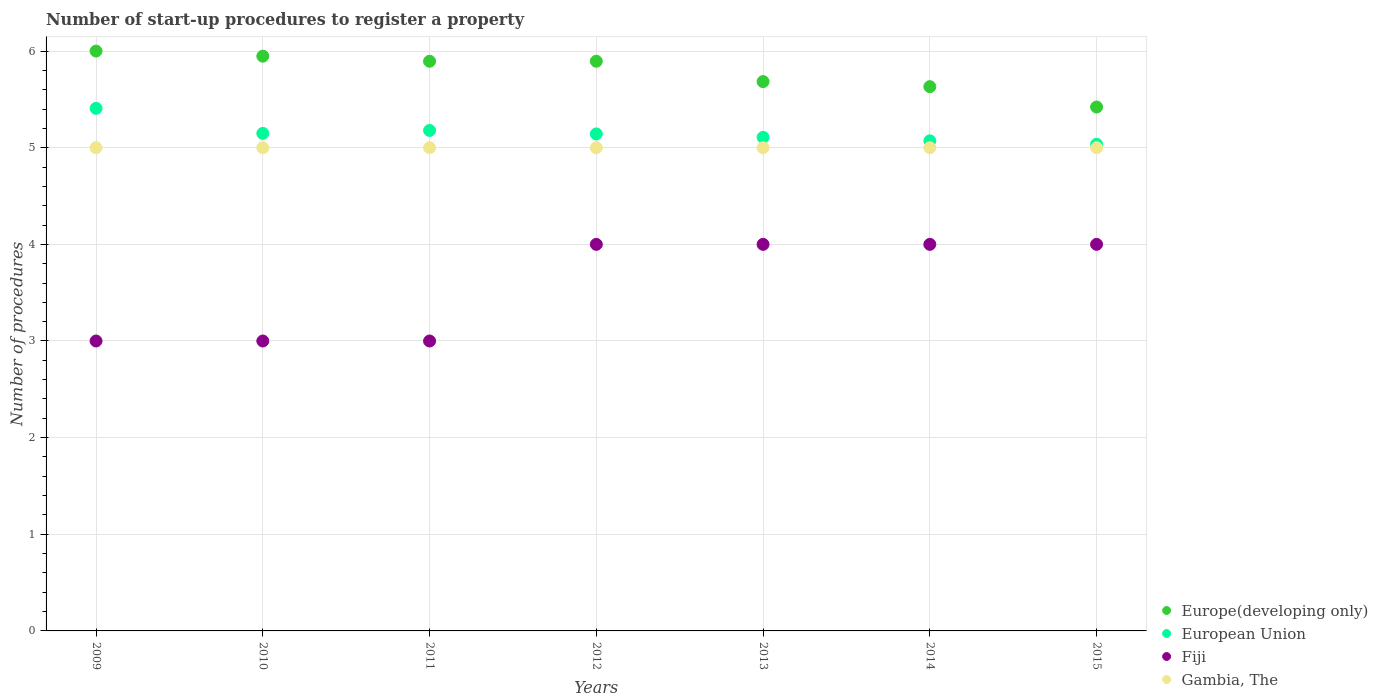What is the number of procedures required to register a property in Fiji in 2013?
Your response must be concise. 4. Across all years, what is the maximum number of procedures required to register a property in European Union?
Offer a very short reply. 5.41. Across all years, what is the minimum number of procedures required to register a property in Fiji?
Your answer should be compact. 3. In which year was the number of procedures required to register a property in Gambia, The maximum?
Your answer should be compact. 2009. In which year was the number of procedures required to register a property in Europe(developing only) minimum?
Make the answer very short. 2015. What is the total number of procedures required to register a property in Europe(developing only) in the graph?
Your response must be concise. 40.47. What is the difference between the number of procedures required to register a property in European Union in 2009 and that in 2012?
Ensure brevity in your answer.  0.26. What is the difference between the number of procedures required to register a property in Europe(developing only) in 2013 and the number of procedures required to register a property in European Union in 2014?
Give a very brief answer. 0.61. What is the average number of procedures required to register a property in European Union per year?
Provide a short and direct response. 5.16. In the year 2011, what is the difference between the number of procedures required to register a property in European Union and number of procedures required to register a property in Gambia, The?
Make the answer very short. 0.18. In how many years, is the number of procedures required to register a property in European Union greater than 5.2?
Ensure brevity in your answer.  1. Is the difference between the number of procedures required to register a property in European Union in 2011 and 2014 greater than the difference between the number of procedures required to register a property in Gambia, The in 2011 and 2014?
Provide a short and direct response. Yes. What is the difference between the highest and the second highest number of procedures required to register a property in Fiji?
Provide a succinct answer. 0. What is the difference between the highest and the lowest number of procedures required to register a property in Europe(developing only)?
Give a very brief answer. 0.58. In how many years, is the number of procedures required to register a property in Fiji greater than the average number of procedures required to register a property in Fiji taken over all years?
Your answer should be very brief. 4. Is it the case that in every year, the sum of the number of procedures required to register a property in Gambia, The and number of procedures required to register a property in Europe(developing only)  is greater than the number of procedures required to register a property in European Union?
Your answer should be compact. Yes. Does the number of procedures required to register a property in Fiji monotonically increase over the years?
Give a very brief answer. No. Is the number of procedures required to register a property in Fiji strictly greater than the number of procedures required to register a property in European Union over the years?
Offer a very short reply. No. How many dotlines are there?
Offer a very short reply. 4. How many years are there in the graph?
Offer a terse response. 7. What is the difference between two consecutive major ticks on the Y-axis?
Your answer should be compact. 1. Does the graph contain any zero values?
Offer a terse response. No. Does the graph contain grids?
Offer a very short reply. Yes. Where does the legend appear in the graph?
Your answer should be compact. Bottom right. What is the title of the graph?
Your response must be concise. Number of start-up procedures to register a property. Does "Cambodia" appear as one of the legend labels in the graph?
Your answer should be compact. No. What is the label or title of the Y-axis?
Keep it short and to the point. Number of procedures. What is the Number of procedures in European Union in 2009?
Your answer should be compact. 5.41. What is the Number of procedures in Fiji in 2009?
Your answer should be compact. 3. What is the Number of procedures of Europe(developing only) in 2010?
Make the answer very short. 5.95. What is the Number of procedures of European Union in 2010?
Make the answer very short. 5.15. What is the Number of procedures of Europe(developing only) in 2011?
Your response must be concise. 5.89. What is the Number of procedures of European Union in 2011?
Offer a terse response. 5.18. What is the Number of procedures in Gambia, The in 2011?
Offer a very short reply. 5. What is the Number of procedures of Europe(developing only) in 2012?
Provide a short and direct response. 5.89. What is the Number of procedures in European Union in 2012?
Provide a succinct answer. 5.14. What is the Number of procedures of Europe(developing only) in 2013?
Your answer should be compact. 5.68. What is the Number of procedures of European Union in 2013?
Provide a succinct answer. 5.11. What is the Number of procedures of Europe(developing only) in 2014?
Ensure brevity in your answer.  5.63. What is the Number of procedures in European Union in 2014?
Your response must be concise. 5.07. What is the Number of procedures of Gambia, The in 2014?
Make the answer very short. 5. What is the Number of procedures in Europe(developing only) in 2015?
Keep it short and to the point. 5.42. What is the Number of procedures of European Union in 2015?
Your answer should be very brief. 5.04. What is the Number of procedures in Fiji in 2015?
Your answer should be compact. 4. What is the Number of procedures in Gambia, The in 2015?
Offer a very short reply. 5. Across all years, what is the maximum Number of procedures of European Union?
Ensure brevity in your answer.  5.41. Across all years, what is the maximum Number of procedures in Fiji?
Give a very brief answer. 4. Across all years, what is the minimum Number of procedures in Europe(developing only)?
Give a very brief answer. 5.42. Across all years, what is the minimum Number of procedures in European Union?
Provide a succinct answer. 5.04. Across all years, what is the minimum Number of procedures of Gambia, The?
Ensure brevity in your answer.  5. What is the total Number of procedures in Europe(developing only) in the graph?
Provide a short and direct response. 40.47. What is the total Number of procedures of European Union in the graph?
Your answer should be very brief. 36.09. What is the total Number of procedures in Gambia, The in the graph?
Ensure brevity in your answer.  35. What is the difference between the Number of procedures of Europe(developing only) in 2009 and that in 2010?
Make the answer very short. 0.05. What is the difference between the Number of procedures of European Union in 2009 and that in 2010?
Provide a short and direct response. 0.26. What is the difference between the Number of procedures in Fiji in 2009 and that in 2010?
Your response must be concise. 0. What is the difference between the Number of procedures of Gambia, The in 2009 and that in 2010?
Give a very brief answer. 0. What is the difference between the Number of procedures in Europe(developing only) in 2009 and that in 2011?
Provide a succinct answer. 0.11. What is the difference between the Number of procedures in European Union in 2009 and that in 2011?
Make the answer very short. 0.23. What is the difference between the Number of procedures of Fiji in 2009 and that in 2011?
Your response must be concise. 0. What is the difference between the Number of procedures of Europe(developing only) in 2009 and that in 2012?
Offer a terse response. 0.11. What is the difference between the Number of procedures of European Union in 2009 and that in 2012?
Your answer should be very brief. 0.26. What is the difference between the Number of procedures in Fiji in 2009 and that in 2012?
Make the answer very short. -1. What is the difference between the Number of procedures in Gambia, The in 2009 and that in 2012?
Provide a succinct answer. 0. What is the difference between the Number of procedures in Europe(developing only) in 2009 and that in 2013?
Make the answer very short. 0.32. What is the difference between the Number of procedures of European Union in 2009 and that in 2013?
Offer a terse response. 0.3. What is the difference between the Number of procedures of Europe(developing only) in 2009 and that in 2014?
Offer a very short reply. 0.37. What is the difference between the Number of procedures in European Union in 2009 and that in 2014?
Your response must be concise. 0.34. What is the difference between the Number of procedures of Europe(developing only) in 2009 and that in 2015?
Keep it short and to the point. 0.58. What is the difference between the Number of procedures of European Union in 2009 and that in 2015?
Your answer should be compact. 0.37. What is the difference between the Number of procedures of Gambia, The in 2009 and that in 2015?
Provide a succinct answer. 0. What is the difference between the Number of procedures in Europe(developing only) in 2010 and that in 2011?
Your answer should be very brief. 0.05. What is the difference between the Number of procedures of European Union in 2010 and that in 2011?
Ensure brevity in your answer.  -0.03. What is the difference between the Number of procedures in Fiji in 2010 and that in 2011?
Give a very brief answer. 0. What is the difference between the Number of procedures of Europe(developing only) in 2010 and that in 2012?
Provide a succinct answer. 0.05. What is the difference between the Number of procedures in European Union in 2010 and that in 2012?
Provide a short and direct response. 0.01. What is the difference between the Number of procedures of Gambia, The in 2010 and that in 2012?
Make the answer very short. 0. What is the difference between the Number of procedures in Europe(developing only) in 2010 and that in 2013?
Keep it short and to the point. 0.26. What is the difference between the Number of procedures of European Union in 2010 and that in 2013?
Ensure brevity in your answer.  0.04. What is the difference between the Number of procedures in Fiji in 2010 and that in 2013?
Your answer should be very brief. -1. What is the difference between the Number of procedures in Gambia, The in 2010 and that in 2013?
Your response must be concise. 0. What is the difference between the Number of procedures in Europe(developing only) in 2010 and that in 2014?
Provide a short and direct response. 0.32. What is the difference between the Number of procedures of European Union in 2010 and that in 2014?
Offer a very short reply. 0.08. What is the difference between the Number of procedures of Gambia, The in 2010 and that in 2014?
Make the answer very short. 0. What is the difference between the Number of procedures of Europe(developing only) in 2010 and that in 2015?
Your answer should be very brief. 0.53. What is the difference between the Number of procedures in European Union in 2010 and that in 2015?
Keep it short and to the point. 0.11. What is the difference between the Number of procedures of Fiji in 2010 and that in 2015?
Provide a short and direct response. -1. What is the difference between the Number of procedures of Europe(developing only) in 2011 and that in 2012?
Offer a very short reply. 0. What is the difference between the Number of procedures of European Union in 2011 and that in 2012?
Provide a succinct answer. 0.04. What is the difference between the Number of procedures of Europe(developing only) in 2011 and that in 2013?
Make the answer very short. 0.21. What is the difference between the Number of procedures in European Union in 2011 and that in 2013?
Give a very brief answer. 0.07. What is the difference between the Number of procedures of Fiji in 2011 and that in 2013?
Offer a terse response. -1. What is the difference between the Number of procedures in Europe(developing only) in 2011 and that in 2014?
Your answer should be very brief. 0.26. What is the difference between the Number of procedures of European Union in 2011 and that in 2014?
Your answer should be very brief. 0.11. What is the difference between the Number of procedures in Fiji in 2011 and that in 2014?
Keep it short and to the point. -1. What is the difference between the Number of procedures in Europe(developing only) in 2011 and that in 2015?
Ensure brevity in your answer.  0.47. What is the difference between the Number of procedures in European Union in 2011 and that in 2015?
Provide a succinct answer. 0.14. What is the difference between the Number of procedures in Gambia, The in 2011 and that in 2015?
Your answer should be very brief. 0. What is the difference between the Number of procedures of Europe(developing only) in 2012 and that in 2013?
Ensure brevity in your answer.  0.21. What is the difference between the Number of procedures in European Union in 2012 and that in 2013?
Make the answer very short. 0.04. What is the difference between the Number of procedures in Fiji in 2012 and that in 2013?
Ensure brevity in your answer.  0. What is the difference between the Number of procedures of Gambia, The in 2012 and that in 2013?
Provide a succinct answer. 0. What is the difference between the Number of procedures in Europe(developing only) in 2012 and that in 2014?
Make the answer very short. 0.26. What is the difference between the Number of procedures of European Union in 2012 and that in 2014?
Offer a terse response. 0.07. What is the difference between the Number of procedures in Gambia, The in 2012 and that in 2014?
Give a very brief answer. 0. What is the difference between the Number of procedures of Europe(developing only) in 2012 and that in 2015?
Your answer should be very brief. 0.47. What is the difference between the Number of procedures of European Union in 2012 and that in 2015?
Ensure brevity in your answer.  0.11. What is the difference between the Number of procedures of Fiji in 2012 and that in 2015?
Provide a short and direct response. 0. What is the difference between the Number of procedures in Gambia, The in 2012 and that in 2015?
Your response must be concise. 0. What is the difference between the Number of procedures of Europe(developing only) in 2013 and that in 2014?
Offer a very short reply. 0.05. What is the difference between the Number of procedures of European Union in 2013 and that in 2014?
Your response must be concise. 0.04. What is the difference between the Number of procedures in Gambia, The in 2013 and that in 2014?
Offer a very short reply. 0. What is the difference between the Number of procedures of Europe(developing only) in 2013 and that in 2015?
Ensure brevity in your answer.  0.26. What is the difference between the Number of procedures in European Union in 2013 and that in 2015?
Your response must be concise. 0.07. What is the difference between the Number of procedures of Fiji in 2013 and that in 2015?
Give a very brief answer. 0. What is the difference between the Number of procedures in Gambia, The in 2013 and that in 2015?
Ensure brevity in your answer.  0. What is the difference between the Number of procedures in Europe(developing only) in 2014 and that in 2015?
Make the answer very short. 0.21. What is the difference between the Number of procedures in European Union in 2014 and that in 2015?
Ensure brevity in your answer.  0.04. What is the difference between the Number of procedures in Fiji in 2014 and that in 2015?
Keep it short and to the point. 0. What is the difference between the Number of procedures of Europe(developing only) in 2009 and the Number of procedures of European Union in 2010?
Give a very brief answer. 0.85. What is the difference between the Number of procedures of Europe(developing only) in 2009 and the Number of procedures of Fiji in 2010?
Offer a terse response. 3. What is the difference between the Number of procedures of European Union in 2009 and the Number of procedures of Fiji in 2010?
Offer a very short reply. 2.41. What is the difference between the Number of procedures of European Union in 2009 and the Number of procedures of Gambia, The in 2010?
Ensure brevity in your answer.  0.41. What is the difference between the Number of procedures of Europe(developing only) in 2009 and the Number of procedures of European Union in 2011?
Offer a terse response. 0.82. What is the difference between the Number of procedures in European Union in 2009 and the Number of procedures in Fiji in 2011?
Your response must be concise. 2.41. What is the difference between the Number of procedures of European Union in 2009 and the Number of procedures of Gambia, The in 2011?
Provide a succinct answer. 0.41. What is the difference between the Number of procedures of Europe(developing only) in 2009 and the Number of procedures of Gambia, The in 2012?
Offer a very short reply. 1. What is the difference between the Number of procedures in European Union in 2009 and the Number of procedures in Fiji in 2012?
Give a very brief answer. 1.41. What is the difference between the Number of procedures of European Union in 2009 and the Number of procedures of Gambia, The in 2012?
Your answer should be very brief. 0.41. What is the difference between the Number of procedures in Europe(developing only) in 2009 and the Number of procedures in European Union in 2013?
Provide a succinct answer. 0.89. What is the difference between the Number of procedures in Europe(developing only) in 2009 and the Number of procedures in Fiji in 2013?
Provide a succinct answer. 2. What is the difference between the Number of procedures of European Union in 2009 and the Number of procedures of Fiji in 2013?
Your answer should be compact. 1.41. What is the difference between the Number of procedures of European Union in 2009 and the Number of procedures of Gambia, The in 2013?
Keep it short and to the point. 0.41. What is the difference between the Number of procedures of Fiji in 2009 and the Number of procedures of Gambia, The in 2013?
Provide a short and direct response. -2. What is the difference between the Number of procedures in Europe(developing only) in 2009 and the Number of procedures in Gambia, The in 2014?
Give a very brief answer. 1. What is the difference between the Number of procedures of European Union in 2009 and the Number of procedures of Fiji in 2014?
Offer a very short reply. 1.41. What is the difference between the Number of procedures of European Union in 2009 and the Number of procedures of Gambia, The in 2014?
Offer a terse response. 0.41. What is the difference between the Number of procedures in Fiji in 2009 and the Number of procedures in Gambia, The in 2014?
Make the answer very short. -2. What is the difference between the Number of procedures of Europe(developing only) in 2009 and the Number of procedures of European Union in 2015?
Keep it short and to the point. 0.96. What is the difference between the Number of procedures in Europe(developing only) in 2009 and the Number of procedures in Fiji in 2015?
Provide a succinct answer. 2. What is the difference between the Number of procedures in Europe(developing only) in 2009 and the Number of procedures in Gambia, The in 2015?
Your answer should be very brief. 1. What is the difference between the Number of procedures of European Union in 2009 and the Number of procedures of Fiji in 2015?
Make the answer very short. 1.41. What is the difference between the Number of procedures in European Union in 2009 and the Number of procedures in Gambia, The in 2015?
Give a very brief answer. 0.41. What is the difference between the Number of procedures in Fiji in 2009 and the Number of procedures in Gambia, The in 2015?
Make the answer very short. -2. What is the difference between the Number of procedures of Europe(developing only) in 2010 and the Number of procedures of European Union in 2011?
Offer a terse response. 0.77. What is the difference between the Number of procedures of Europe(developing only) in 2010 and the Number of procedures of Fiji in 2011?
Your response must be concise. 2.95. What is the difference between the Number of procedures of Europe(developing only) in 2010 and the Number of procedures of Gambia, The in 2011?
Give a very brief answer. 0.95. What is the difference between the Number of procedures in European Union in 2010 and the Number of procedures in Fiji in 2011?
Your answer should be compact. 2.15. What is the difference between the Number of procedures in European Union in 2010 and the Number of procedures in Gambia, The in 2011?
Give a very brief answer. 0.15. What is the difference between the Number of procedures in Europe(developing only) in 2010 and the Number of procedures in European Union in 2012?
Give a very brief answer. 0.8. What is the difference between the Number of procedures of Europe(developing only) in 2010 and the Number of procedures of Fiji in 2012?
Offer a terse response. 1.95. What is the difference between the Number of procedures of Europe(developing only) in 2010 and the Number of procedures of Gambia, The in 2012?
Ensure brevity in your answer.  0.95. What is the difference between the Number of procedures in European Union in 2010 and the Number of procedures in Fiji in 2012?
Provide a succinct answer. 1.15. What is the difference between the Number of procedures of European Union in 2010 and the Number of procedures of Gambia, The in 2012?
Provide a succinct answer. 0.15. What is the difference between the Number of procedures of Fiji in 2010 and the Number of procedures of Gambia, The in 2012?
Give a very brief answer. -2. What is the difference between the Number of procedures in Europe(developing only) in 2010 and the Number of procedures in European Union in 2013?
Your answer should be very brief. 0.84. What is the difference between the Number of procedures of Europe(developing only) in 2010 and the Number of procedures of Fiji in 2013?
Your response must be concise. 1.95. What is the difference between the Number of procedures of Europe(developing only) in 2010 and the Number of procedures of Gambia, The in 2013?
Ensure brevity in your answer.  0.95. What is the difference between the Number of procedures of European Union in 2010 and the Number of procedures of Fiji in 2013?
Keep it short and to the point. 1.15. What is the difference between the Number of procedures in European Union in 2010 and the Number of procedures in Gambia, The in 2013?
Provide a succinct answer. 0.15. What is the difference between the Number of procedures in Europe(developing only) in 2010 and the Number of procedures in European Union in 2014?
Make the answer very short. 0.88. What is the difference between the Number of procedures of Europe(developing only) in 2010 and the Number of procedures of Fiji in 2014?
Provide a short and direct response. 1.95. What is the difference between the Number of procedures of Europe(developing only) in 2010 and the Number of procedures of Gambia, The in 2014?
Keep it short and to the point. 0.95. What is the difference between the Number of procedures of European Union in 2010 and the Number of procedures of Fiji in 2014?
Your response must be concise. 1.15. What is the difference between the Number of procedures in European Union in 2010 and the Number of procedures in Gambia, The in 2014?
Ensure brevity in your answer.  0.15. What is the difference between the Number of procedures of Europe(developing only) in 2010 and the Number of procedures of European Union in 2015?
Offer a terse response. 0.91. What is the difference between the Number of procedures of Europe(developing only) in 2010 and the Number of procedures of Fiji in 2015?
Provide a succinct answer. 1.95. What is the difference between the Number of procedures of Europe(developing only) in 2010 and the Number of procedures of Gambia, The in 2015?
Provide a short and direct response. 0.95. What is the difference between the Number of procedures of European Union in 2010 and the Number of procedures of Fiji in 2015?
Provide a short and direct response. 1.15. What is the difference between the Number of procedures of European Union in 2010 and the Number of procedures of Gambia, The in 2015?
Make the answer very short. 0.15. What is the difference between the Number of procedures of Europe(developing only) in 2011 and the Number of procedures of European Union in 2012?
Provide a succinct answer. 0.75. What is the difference between the Number of procedures in Europe(developing only) in 2011 and the Number of procedures in Fiji in 2012?
Your answer should be compact. 1.89. What is the difference between the Number of procedures in Europe(developing only) in 2011 and the Number of procedures in Gambia, The in 2012?
Provide a succinct answer. 0.89. What is the difference between the Number of procedures in European Union in 2011 and the Number of procedures in Fiji in 2012?
Your answer should be very brief. 1.18. What is the difference between the Number of procedures in European Union in 2011 and the Number of procedures in Gambia, The in 2012?
Provide a succinct answer. 0.18. What is the difference between the Number of procedures of Europe(developing only) in 2011 and the Number of procedures of European Union in 2013?
Provide a succinct answer. 0.79. What is the difference between the Number of procedures of Europe(developing only) in 2011 and the Number of procedures of Fiji in 2013?
Offer a terse response. 1.89. What is the difference between the Number of procedures in Europe(developing only) in 2011 and the Number of procedures in Gambia, The in 2013?
Your answer should be very brief. 0.89. What is the difference between the Number of procedures of European Union in 2011 and the Number of procedures of Fiji in 2013?
Offer a terse response. 1.18. What is the difference between the Number of procedures in European Union in 2011 and the Number of procedures in Gambia, The in 2013?
Make the answer very short. 0.18. What is the difference between the Number of procedures of Europe(developing only) in 2011 and the Number of procedures of European Union in 2014?
Your response must be concise. 0.82. What is the difference between the Number of procedures of Europe(developing only) in 2011 and the Number of procedures of Fiji in 2014?
Provide a short and direct response. 1.89. What is the difference between the Number of procedures of Europe(developing only) in 2011 and the Number of procedures of Gambia, The in 2014?
Provide a short and direct response. 0.89. What is the difference between the Number of procedures in European Union in 2011 and the Number of procedures in Fiji in 2014?
Provide a succinct answer. 1.18. What is the difference between the Number of procedures in European Union in 2011 and the Number of procedures in Gambia, The in 2014?
Give a very brief answer. 0.18. What is the difference between the Number of procedures of Fiji in 2011 and the Number of procedures of Gambia, The in 2014?
Your response must be concise. -2. What is the difference between the Number of procedures of Europe(developing only) in 2011 and the Number of procedures of European Union in 2015?
Offer a terse response. 0.86. What is the difference between the Number of procedures in Europe(developing only) in 2011 and the Number of procedures in Fiji in 2015?
Ensure brevity in your answer.  1.89. What is the difference between the Number of procedures in Europe(developing only) in 2011 and the Number of procedures in Gambia, The in 2015?
Offer a very short reply. 0.89. What is the difference between the Number of procedures in European Union in 2011 and the Number of procedures in Fiji in 2015?
Offer a terse response. 1.18. What is the difference between the Number of procedures of European Union in 2011 and the Number of procedures of Gambia, The in 2015?
Your answer should be compact. 0.18. What is the difference between the Number of procedures of Europe(developing only) in 2012 and the Number of procedures of European Union in 2013?
Keep it short and to the point. 0.79. What is the difference between the Number of procedures of Europe(developing only) in 2012 and the Number of procedures of Fiji in 2013?
Make the answer very short. 1.89. What is the difference between the Number of procedures of Europe(developing only) in 2012 and the Number of procedures of Gambia, The in 2013?
Provide a short and direct response. 0.89. What is the difference between the Number of procedures in European Union in 2012 and the Number of procedures in Gambia, The in 2013?
Offer a very short reply. 0.14. What is the difference between the Number of procedures in Europe(developing only) in 2012 and the Number of procedures in European Union in 2014?
Keep it short and to the point. 0.82. What is the difference between the Number of procedures in Europe(developing only) in 2012 and the Number of procedures in Fiji in 2014?
Provide a succinct answer. 1.89. What is the difference between the Number of procedures of Europe(developing only) in 2012 and the Number of procedures of Gambia, The in 2014?
Provide a succinct answer. 0.89. What is the difference between the Number of procedures of European Union in 2012 and the Number of procedures of Gambia, The in 2014?
Give a very brief answer. 0.14. What is the difference between the Number of procedures in Europe(developing only) in 2012 and the Number of procedures in European Union in 2015?
Your answer should be compact. 0.86. What is the difference between the Number of procedures in Europe(developing only) in 2012 and the Number of procedures in Fiji in 2015?
Give a very brief answer. 1.89. What is the difference between the Number of procedures in Europe(developing only) in 2012 and the Number of procedures in Gambia, The in 2015?
Make the answer very short. 0.89. What is the difference between the Number of procedures in European Union in 2012 and the Number of procedures in Gambia, The in 2015?
Offer a terse response. 0.14. What is the difference between the Number of procedures in Fiji in 2012 and the Number of procedures in Gambia, The in 2015?
Make the answer very short. -1. What is the difference between the Number of procedures of Europe(developing only) in 2013 and the Number of procedures of European Union in 2014?
Keep it short and to the point. 0.61. What is the difference between the Number of procedures of Europe(developing only) in 2013 and the Number of procedures of Fiji in 2014?
Your answer should be very brief. 1.68. What is the difference between the Number of procedures of Europe(developing only) in 2013 and the Number of procedures of Gambia, The in 2014?
Provide a short and direct response. 0.68. What is the difference between the Number of procedures of European Union in 2013 and the Number of procedures of Fiji in 2014?
Keep it short and to the point. 1.11. What is the difference between the Number of procedures in European Union in 2013 and the Number of procedures in Gambia, The in 2014?
Offer a very short reply. 0.11. What is the difference between the Number of procedures in Europe(developing only) in 2013 and the Number of procedures in European Union in 2015?
Offer a terse response. 0.65. What is the difference between the Number of procedures in Europe(developing only) in 2013 and the Number of procedures in Fiji in 2015?
Make the answer very short. 1.68. What is the difference between the Number of procedures of Europe(developing only) in 2013 and the Number of procedures of Gambia, The in 2015?
Offer a very short reply. 0.68. What is the difference between the Number of procedures in European Union in 2013 and the Number of procedures in Fiji in 2015?
Make the answer very short. 1.11. What is the difference between the Number of procedures of European Union in 2013 and the Number of procedures of Gambia, The in 2015?
Offer a very short reply. 0.11. What is the difference between the Number of procedures of Europe(developing only) in 2014 and the Number of procedures of European Union in 2015?
Your answer should be compact. 0.6. What is the difference between the Number of procedures in Europe(developing only) in 2014 and the Number of procedures in Fiji in 2015?
Keep it short and to the point. 1.63. What is the difference between the Number of procedures in Europe(developing only) in 2014 and the Number of procedures in Gambia, The in 2015?
Your answer should be very brief. 0.63. What is the difference between the Number of procedures of European Union in 2014 and the Number of procedures of Fiji in 2015?
Your answer should be compact. 1.07. What is the difference between the Number of procedures of European Union in 2014 and the Number of procedures of Gambia, The in 2015?
Give a very brief answer. 0.07. What is the average Number of procedures in Europe(developing only) per year?
Make the answer very short. 5.78. What is the average Number of procedures of European Union per year?
Your response must be concise. 5.16. What is the average Number of procedures in Fiji per year?
Provide a short and direct response. 3.57. What is the average Number of procedures of Gambia, The per year?
Keep it short and to the point. 5. In the year 2009, what is the difference between the Number of procedures of Europe(developing only) and Number of procedures of European Union?
Your response must be concise. 0.59. In the year 2009, what is the difference between the Number of procedures in European Union and Number of procedures in Fiji?
Your answer should be very brief. 2.41. In the year 2009, what is the difference between the Number of procedures in European Union and Number of procedures in Gambia, The?
Keep it short and to the point. 0.41. In the year 2009, what is the difference between the Number of procedures of Fiji and Number of procedures of Gambia, The?
Your answer should be compact. -2. In the year 2010, what is the difference between the Number of procedures of Europe(developing only) and Number of procedures of European Union?
Provide a short and direct response. 0.8. In the year 2010, what is the difference between the Number of procedures of Europe(developing only) and Number of procedures of Fiji?
Your response must be concise. 2.95. In the year 2010, what is the difference between the Number of procedures of Europe(developing only) and Number of procedures of Gambia, The?
Your answer should be compact. 0.95. In the year 2010, what is the difference between the Number of procedures of European Union and Number of procedures of Fiji?
Your answer should be very brief. 2.15. In the year 2010, what is the difference between the Number of procedures in European Union and Number of procedures in Gambia, The?
Keep it short and to the point. 0.15. In the year 2010, what is the difference between the Number of procedures in Fiji and Number of procedures in Gambia, The?
Ensure brevity in your answer.  -2. In the year 2011, what is the difference between the Number of procedures in Europe(developing only) and Number of procedures in European Union?
Keep it short and to the point. 0.72. In the year 2011, what is the difference between the Number of procedures in Europe(developing only) and Number of procedures in Fiji?
Offer a very short reply. 2.89. In the year 2011, what is the difference between the Number of procedures of Europe(developing only) and Number of procedures of Gambia, The?
Offer a terse response. 0.89. In the year 2011, what is the difference between the Number of procedures in European Union and Number of procedures in Fiji?
Ensure brevity in your answer.  2.18. In the year 2011, what is the difference between the Number of procedures in European Union and Number of procedures in Gambia, The?
Make the answer very short. 0.18. In the year 2012, what is the difference between the Number of procedures in Europe(developing only) and Number of procedures in European Union?
Offer a very short reply. 0.75. In the year 2012, what is the difference between the Number of procedures in Europe(developing only) and Number of procedures in Fiji?
Provide a short and direct response. 1.89. In the year 2012, what is the difference between the Number of procedures of Europe(developing only) and Number of procedures of Gambia, The?
Provide a succinct answer. 0.89. In the year 2012, what is the difference between the Number of procedures of European Union and Number of procedures of Fiji?
Your answer should be very brief. 1.14. In the year 2012, what is the difference between the Number of procedures in European Union and Number of procedures in Gambia, The?
Provide a succinct answer. 0.14. In the year 2012, what is the difference between the Number of procedures of Fiji and Number of procedures of Gambia, The?
Make the answer very short. -1. In the year 2013, what is the difference between the Number of procedures of Europe(developing only) and Number of procedures of European Union?
Provide a succinct answer. 0.58. In the year 2013, what is the difference between the Number of procedures in Europe(developing only) and Number of procedures in Fiji?
Your answer should be compact. 1.68. In the year 2013, what is the difference between the Number of procedures in Europe(developing only) and Number of procedures in Gambia, The?
Your response must be concise. 0.68. In the year 2013, what is the difference between the Number of procedures in European Union and Number of procedures in Fiji?
Make the answer very short. 1.11. In the year 2013, what is the difference between the Number of procedures of European Union and Number of procedures of Gambia, The?
Keep it short and to the point. 0.11. In the year 2014, what is the difference between the Number of procedures of Europe(developing only) and Number of procedures of European Union?
Your answer should be compact. 0.56. In the year 2014, what is the difference between the Number of procedures in Europe(developing only) and Number of procedures in Fiji?
Keep it short and to the point. 1.63. In the year 2014, what is the difference between the Number of procedures in Europe(developing only) and Number of procedures in Gambia, The?
Your answer should be very brief. 0.63. In the year 2014, what is the difference between the Number of procedures in European Union and Number of procedures in Fiji?
Make the answer very short. 1.07. In the year 2014, what is the difference between the Number of procedures in European Union and Number of procedures in Gambia, The?
Offer a very short reply. 0.07. In the year 2014, what is the difference between the Number of procedures of Fiji and Number of procedures of Gambia, The?
Offer a terse response. -1. In the year 2015, what is the difference between the Number of procedures in Europe(developing only) and Number of procedures in European Union?
Ensure brevity in your answer.  0.39. In the year 2015, what is the difference between the Number of procedures in Europe(developing only) and Number of procedures in Fiji?
Your answer should be very brief. 1.42. In the year 2015, what is the difference between the Number of procedures in Europe(developing only) and Number of procedures in Gambia, The?
Your response must be concise. 0.42. In the year 2015, what is the difference between the Number of procedures in European Union and Number of procedures in Fiji?
Ensure brevity in your answer.  1.04. In the year 2015, what is the difference between the Number of procedures of European Union and Number of procedures of Gambia, The?
Your answer should be very brief. 0.04. What is the ratio of the Number of procedures in Europe(developing only) in 2009 to that in 2010?
Keep it short and to the point. 1.01. What is the ratio of the Number of procedures in European Union in 2009 to that in 2010?
Offer a very short reply. 1.05. What is the ratio of the Number of procedures of Fiji in 2009 to that in 2010?
Make the answer very short. 1. What is the ratio of the Number of procedures of Gambia, The in 2009 to that in 2010?
Make the answer very short. 1. What is the ratio of the Number of procedures in Europe(developing only) in 2009 to that in 2011?
Offer a terse response. 1.02. What is the ratio of the Number of procedures in European Union in 2009 to that in 2011?
Keep it short and to the point. 1.04. What is the ratio of the Number of procedures of Fiji in 2009 to that in 2011?
Give a very brief answer. 1. What is the ratio of the Number of procedures in Europe(developing only) in 2009 to that in 2012?
Offer a terse response. 1.02. What is the ratio of the Number of procedures of European Union in 2009 to that in 2012?
Provide a succinct answer. 1.05. What is the ratio of the Number of procedures in Fiji in 2009 to that in 2012?
Your answer should be compact. 0.75. What is the ratio of the Number of procedures in Europe(developing only) in 2009 to that in 2013?
Make the answer very short. 1.06. What is the ratio of the Number of procedures of European Union in 2009 to that in 2013?
Give a very brief answer. 1.06. What is the ratio of the Number of procedures of Fiji in 2009 to that in 2013?
Your answer should be compact. 0.75. What is the ratio of the Number of procedures in Europe(developing only) in 2009 to that in 2014?
Keep it short and to the point. 1.07. What is the ratio of the Number of procedures of European Union in 2009 to that in 2014?
Your response must be concise. 1.07. What is the ratio of the Number of procedures in Europe(developing only) in 2009 to that in 2015?
Your answer should be very brief. 1.11. What is the ratio of the Number of procedures in European Union in 2009 to that in 2015?
Your response must be concise. 1.07. What is the ratio of the Number of procedures in Gambia, The in 2009 to that in 2015?
Keep it short and to the point. 1. What is the ratio of the Number of procedures of Europe(developing only) in 2010 to that in 2011?
Provide a succinct answer. 1.01. What is the ratio of the Number of procedures of European Union in 2010 to that in 2011?
Offer a terse response. 0.99. What is the ratio of the Number of procedures in Fiji in 2010 to that in 2011?
Make the answer very short. 1. What is the ratio of the Number of procedures in Europe(developing only) in 2010 to that in 2012?
Provide a short and direct response. 1.01. What is the ratio of the Number of procedures in European Union in 2010 to that in 2012?
Give a very brief answer. 1. What is the ratio of the Number of procedures in Fiji in 2010 to that in 2012?
Offer a terse response. 0.75. What is the ratio of the Number of procedures of Gambia, The in 2010 to that in 2012?
Provide a short and direct response. 1. What is the ratio of the Number of procedures of Europe(developing only) in 2010 to that in 2013?
Offer a terse response. 1.05. What is the ratio of the Number of procedures in European Union in 2010 to that in 2013?
Provide a succinct answer. 1.01. What is the ratio of the Number of procedures of Europe(developing only) in 2010 to that in 2014?
Your answer should be compact. 1.06. What is the ratio of the Number of procedures in European Union in 2010 to that in 2014?
Provide a succinct answer. 1.02. What is the ratio of the Number of procedures of Fiji in 2010 to that in 2014?
Make the answer very short. 0.75. What is the ratio of the Number of procedures of Europe(developing only) in 2010 to that in 2015?
Provide a short and direct response. 1.1. What is the ratio of the Number of procedures in European Union in 2010 to that in 2015?
Your response must be concise. 1.02. What is the ratio of the Number of procedures in Fiji in 2010 to that in 2015?
Provide a short and direct response. 0.75. What is the ratio of the Number of procedures in Europe(developing only) in 2011 to that in 2012?
Your answer should be very brief. 1. What is the ratio of the Number of procedures of European Union in 2011 to that in 2012?
Give a very brief answer. 1.01. What is the ratio of the Number of procedures of Gambia, The in 2011 to that in 2012?
Offer a very short reply. 1. What is the ratio of the Number of procedures of Fiji in 2011 to that in 2013?
Provide a succinct answer. 0.75. What is the ratio of the Number of procedures of Europe(developing only) in 2011 to that in 2014?
Make the answer very short. 1.05. What is the ratio of the Number of procedures in European Union in 2011 to that in 2014?
Your answer should be compact. 1.02. What is the ratio of the Number of procedures of Europe(developing only) in 2011 to that in 2015?
Your response must be concise. 1.09. What is the ratio of the Number of procedures in European Union in 2011 to that in 2015?
Your answer should be very brief. 1.03. What is the ratio of the Number of procedures in Fiji in 2011 to that in 2015?
Offer a very short reply. 0.75. What is the ratio of the Number of procedures in Europe(developing only) in 2012 to that in 2013?
Offer a terse response. 1.04. What is the ratio of the Number of procedures in Gambia, The in 2012 to that in 2013?
Offer a very short reply. 1. What is the ratio of the Number of procedures in Europe(developing only) in 2012 to that in 2014?
Your response must be concise. 1.05. What is the ratio of the Number of procedures of European Union in 2012 to that in 2014?
Keep it short and to the point. 1.01. What is the ratio of the Number of procedures of Europe(developing only) in 2012 to that in 2015?
Offer a very short reply. 1.09. What is the ratio of the Number of procedures in European Union in 2012 to that in 2015?
Give a very brief answer. 1.02. What is the ratio of the Number of procedures of Fiji in 2012 to that in 2015?
Give a very brief answer. 1. What is the ratio of the Number of procedures in Gambia, The in 2012 to that in 2015?
Ensure brevity in your answer.  1. What is the ratio of the Number of procedures in Europe(developing only) in 2013 to that in 2014?
Keep it short and to the point. 1.01. What is the ratio of the Number of procedures of European Union in 2013 to that in 2014?
Provide a short and direct response. 1.01. What is the ratio of the Number of procedures in Gambia, The in 2013 to that in 2014?
Provide a succinct answer. 1. What is the ratio of the Number of procedures of Europe(developing only) in 2013 to that in 2015?
Provide a short and direct response. 1.05. What is the ratio of the Number of procedures of European Union in 2013 to that in 2015?
Ensure brevity in your answer.  1.01. What is the ratio of the Number of procedures of Fiji in 2013 to that in 2015?
Your answer should be compact. 1. What is the ratio of the Number of procedures in Europe(developing only) in 2014 to that in 2015?
Offer a terse response. 1.04. What is the ratio of the Number of procedures of European Union in 2014 to that in 2015?
Give a very brief answer. 1.01. What is the ratio of the Number of procedures of Fiji in 2014 to that in 2015?
Your answer should be very brief. 1. What is the difference between the highest and the second highest Number of procedures of Europe(developing only)?
Your answer should be very brief. 0.05. What is the difference between the highest and the second highest Number of procedures in European Union?
Provide a short and direct response. 0.23. What is the difference between the highest and the second highest Number of procedures in Fiji?
Give a very brief answer. 0. What is the difference between the highest and the second highest Number of procedures in Gambia, The?
Your response must be concise. 0. What is the difference between the highest and the lowest Number of procedures of Europe(developing only)?
Provide a short and direct response. 0.58. What is the difference between the highest and the lowest Number of procedures in European Union?
Your answer should be very brief. 0.37. What is the difference between the highest and the lowest Number of procedures of Fiji?
Your response must be concise. 1. 